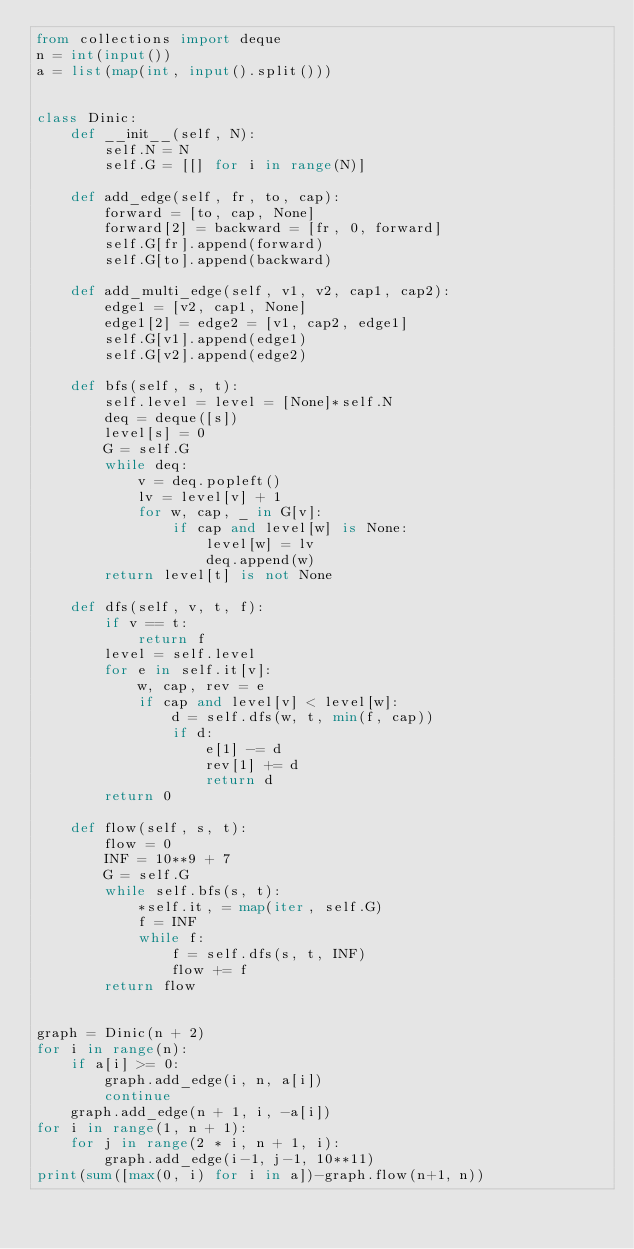<code> <loc_0><loc_0><loc_500><loc_500><_Python_>from collections import deque
n = int(input())
a = list(map(int, input().split()))


class Dinic:
    def __init__(self, N):
        self.N = N
        self.G = [[] for i in range(N)]

    def add_edge(self, fr, to, cap):
        forward = [to, cap, None]
        forward[2] = backward = [fr, 0, forward]
        self.G[fr].append(forward)
        self.G[to].append(backward)

    def add_multi_edge(self, v1, v2, cap1, cap2):
        edge1 = [v2, cap1, None]
        edge1[2] = edge2 = [v1, cap2, edge1]
        self.G[v1].append(edge1)
        self.G[v2].append(edge2)

    def bfs(self, s, t):
        self.level = level = [None]*self.N
        deq = deque([s])
        level[s] = 0
        G = self.G
        while deq:
            v = deq.popleft()
            lv = level[v] + 1
            for w, cap, _ in G[v]:
                if cap and level[w] is None:
                    level[w] = lv
                    deq.append(w)
        return level[t] is not None

    def dfs(self, v, t, f):
        if v == t:
            return f
        level = self.level
        for e in self.it[v]:
            w, cap, rev = e
            if cap and level[v] < level[w]:
                d = self.dfs(w, t, min(f, cap))
                if d:
                    e[1] -= d
                    rev[1] += d
                    return d
        return 0

    def flow(self, s, t):
        flow = 0
        INF = 10**9 + 7
        G = self.G
        while self.bfs(s, t):
            *self.it, = map(iter, self.G)
            f = INF
            while f:
                f = self.dfs(s, t, INF)
                flow += f
        return flow


graph = Dinic(n + 2)
for i in range(n):
    if a[i] >= 0:
        graph.add_edge(i, n, a[i])
        continue
    graph.add_edge(n + 1, i, -a[i])
for i in range(1, n + 1):
    for j in range(2 * i, n + 1, i):
        graph.add_edge(i-1, j-1, 10**11)
print(sum([max(0, i) for i in a])-graph.flow(n+1, n))
</code> 